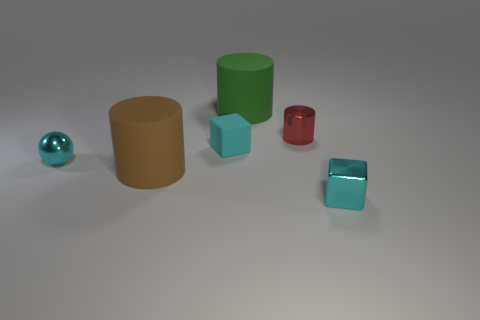There is a small sphere that is the same color as the small shiny cube; what is its material?
Provide a succinct answer. Metal. There is a cyan metal object right of the small cyan sphere; does it have the same size as the red metal cylinder that is on the right side of the brown rubber cylinder?
Offer a very short reply. Yes. There is a cyan metal object left of the matte cylinder that is behind the small red cylinder; how big is it?
Make the answer very short. Small. There is a object that is right of the green matte thing and behind the cyan rubber block; what is it made of?
Keep it short and to the point. Metal. The tiny rubber block has what color?
Provide a short and direct response. Cyan. Are there any other things that have the same material as the tiny cyan sphere?
Ensure brevity in your answer.  Yes. The cyan metallic thing that is to the right of the cyan metal sphere has what shape?
Make the answer very short. Cube. Is there a cyan metallic block that is on the right side of the block to the right of the large green matte cylinder that is to the right of the cyan sphere?
Offer a terse response. No. Is there any other thing that has the same shape as the green rubber thing?
Offer a very short reply. Yes. Are there any brown shiny spheres?
Your answer should be compact. No. 